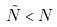<formula> <loc_0><loc_0><loc_500><loc_500>\tilde { N } < N</formula> 